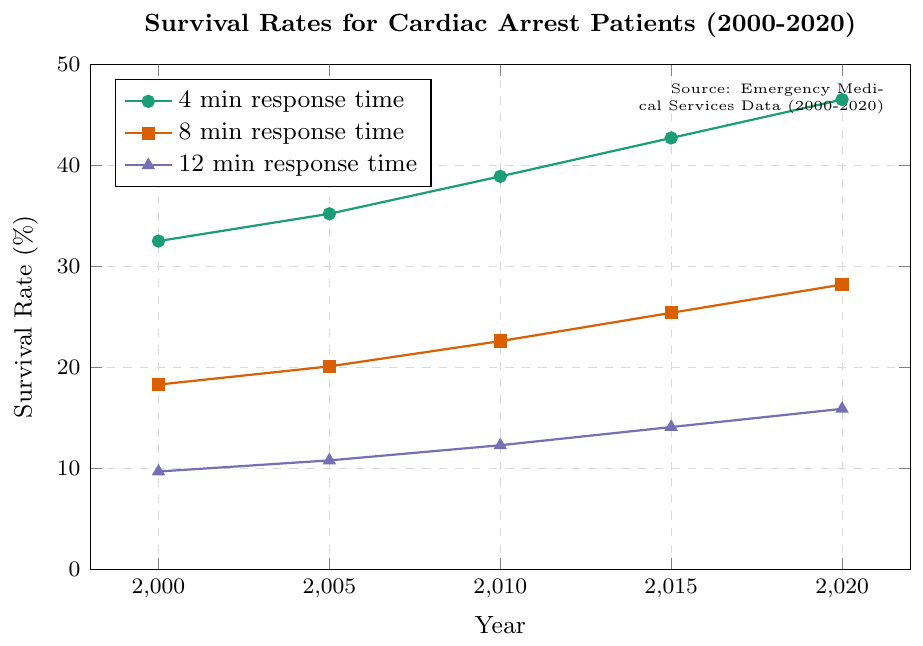What is the survival rate for cardiac arrest patients in 2020 with 4-minute response time? The plot shows data points for survival rates at different response times across various years. For 4-minute response time in 2020, locate the data point on the green line for the year 2020. It corresponds to a survival rate of 46.5%.
Answer: 46.5% What is the difference in survival rates between 4-minute and 12-minute response times in 2000? Locate the survival rates for 4-minute and 12-minute response times for the year 2000 on their respective lines (green and purple). The rates are 32.5% and 9.7%, respectively. The difference is 32.5 - 9.7.
Answer: 22.8% Which response time shows the highest survival rate in 2015? For the year 2015, compare the survival rates of the three colored lines. The green line (4-minute response time) shows the highest rate at 42.7%.
Answer: 4-minute response time How has the survival rate for an 8-minute response time changed from 2000 to 2020? Look at the orange line, which represents the 8-minute response time, and compare the values for the years 2000 and 2020. The survival rate increases from 18.3% to 28.2%. Calculate the change as 28.2 - 18.3.
Answer: 9.9% What is the average survival rate for 12-minute response times from 2000 to 2020? Locate the survival rates for the 12-minute response time (purple line) for all years and calculate the average. The rates are 9.7%, 10.8%, 12.3%, 14.1%, and 15.9%. Sum these and divide by 5: (9.7 + 10.8 + 12.3 + 14.1 + 15.9)/5.
Answer: 12.56% Which year shows the largest increase in survival rate for the 4-minute response time compared to the previous data point? Examine the green line at each subsequent data point and calculate the differences: 35.2 - 32.5 = 2.7 for 2005, 38.9 - 35.2 = 3.7 for 2010, 42.7 - 38.9 = 3.8 for 2015, and 46.5 - 42.7 = 3.8 for 2020. The largest increase is from 2010 to 2015 and 2015 to 2020, both 3.8%.
Answer: 2015 and 2020 What trend can be observed for survival rates with increasing response times for any given year? On each vertical slice of the graph (a specific year), observe the relationship between increasing response times (4 minutes to 12 minutes) and survival rates on the lines (green to purple). In every year, survival rates decrease as response times increase.
Answer: Decreasing trend Between 2005 and 2010, which response time showed the smallest increase in survival rate? Look at the lines between 2005 and 2010. Calculate the increases: Green line: 38.9 - 35.2 = 3.7, Orange line: 22.6 - 20.1 = 2.5, Purple line: 12.3 - 10.8 = 1.5. The smallest increase is seen in the purple line (12-minute response time).
Answer: 12-minute response time What was the survival rate in 2010 for the 8-minute response time, and how does it compare to that in 2000? Locate the survival rates for the 8-minute response time (orange line) in 2010 and 2000. The rates are 22.6% in 2010 and 18.3% in 2000. Compare the rates: 22.6 - 18.3.
Answer: 22.6% in 2010, 4.3% increase from 2000 